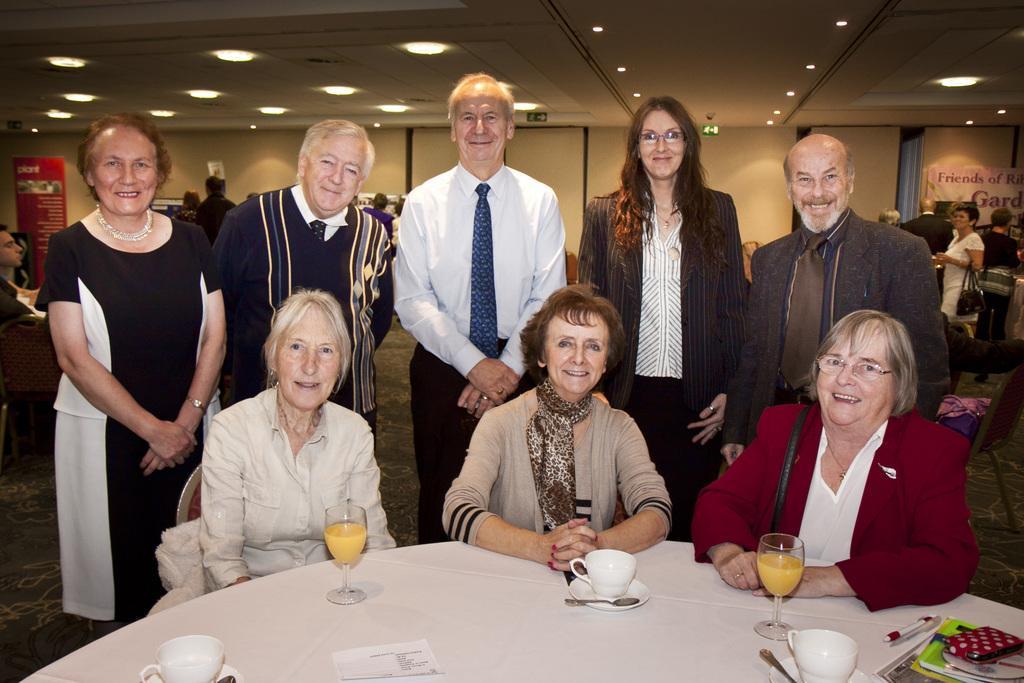How would you summarize this image in a sentence or two? In this picture we can see a few women are sitting on the chair. There are few cups, glasses, spoons, books,a pen and a wallet on the table. Few people are standing at the back. There are some boards and a banner in the background. Some lights are visible on top. 